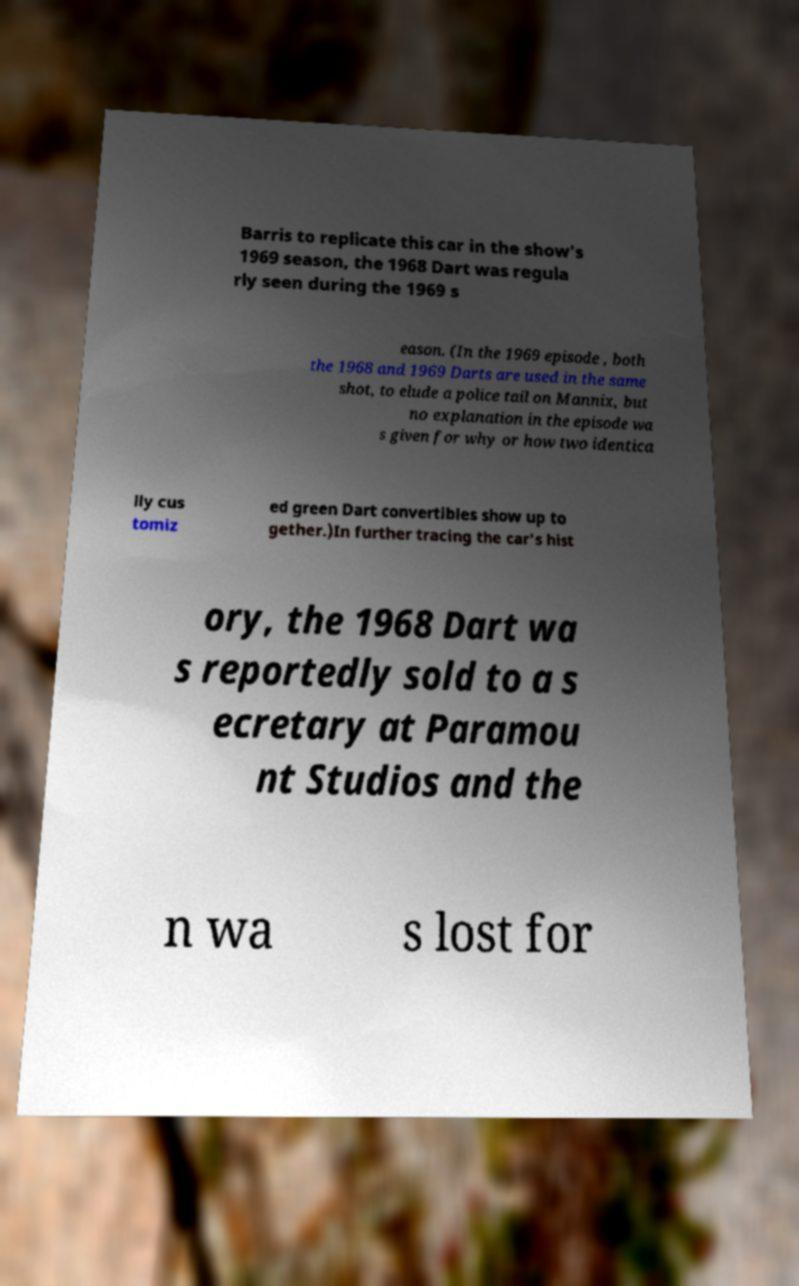I need the written content from this picture converted into text. Can you do that? Barris to replicate this car in the show's 1969 season, the 1968 Dart was regula rly seen during the 1969 s eason. (In the 1969 episode , both the 1968 and 1969 Darts are used in the same shot, to elude a police tail on Mannix, but no explanation in the episode wa s given for why or how two identica lly cus tomiz ed green Dart convertibles show up to gether.)In further tracing the car's hist ory, the 1968 Dart wa s reportedly sold to a s ecretary at Paramou nt Studios and the n wa s lost for 